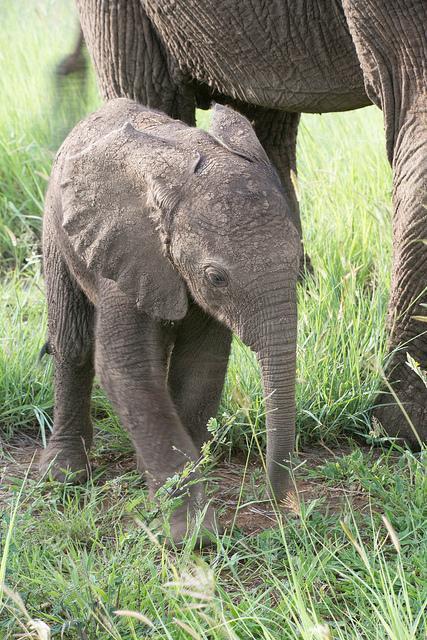How many elephants are there?
Give a very brief answer. 2. How many people in the image have on backpacks?
Give a very brief answer. 0. 